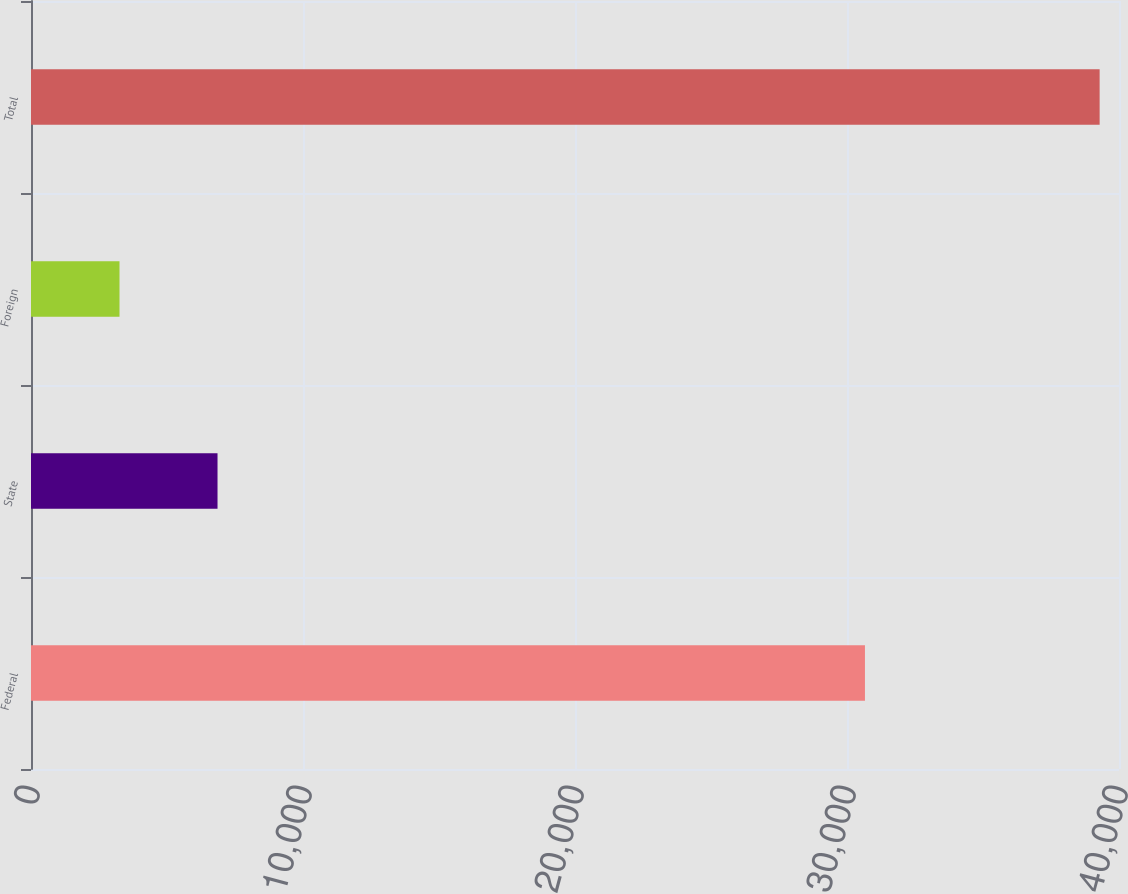Convert chart. <chart><loc_0><loc_0><loc_500><loc_500><bar_chart><fcel>Federal<fcel>State<fcel>Foreign<fcel>Total<nl><fcel>30660<fcel>6857.4<fcel>3254<fcel>39288<nl></chart> 